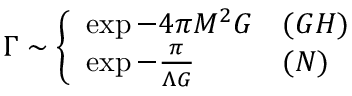Convert formula to latex. <formula><loc_0><loc_0><loc_500><loc_500>\Gamma \sim \left \{ \begin{array} { l l } { { \exp - 4 \pi M ^ { 2 } G } } & { ( G H ) } \\ { { \exp - \frac { \pi } { \Lambda G } } & { ( N ) } \end{array}</formula> 